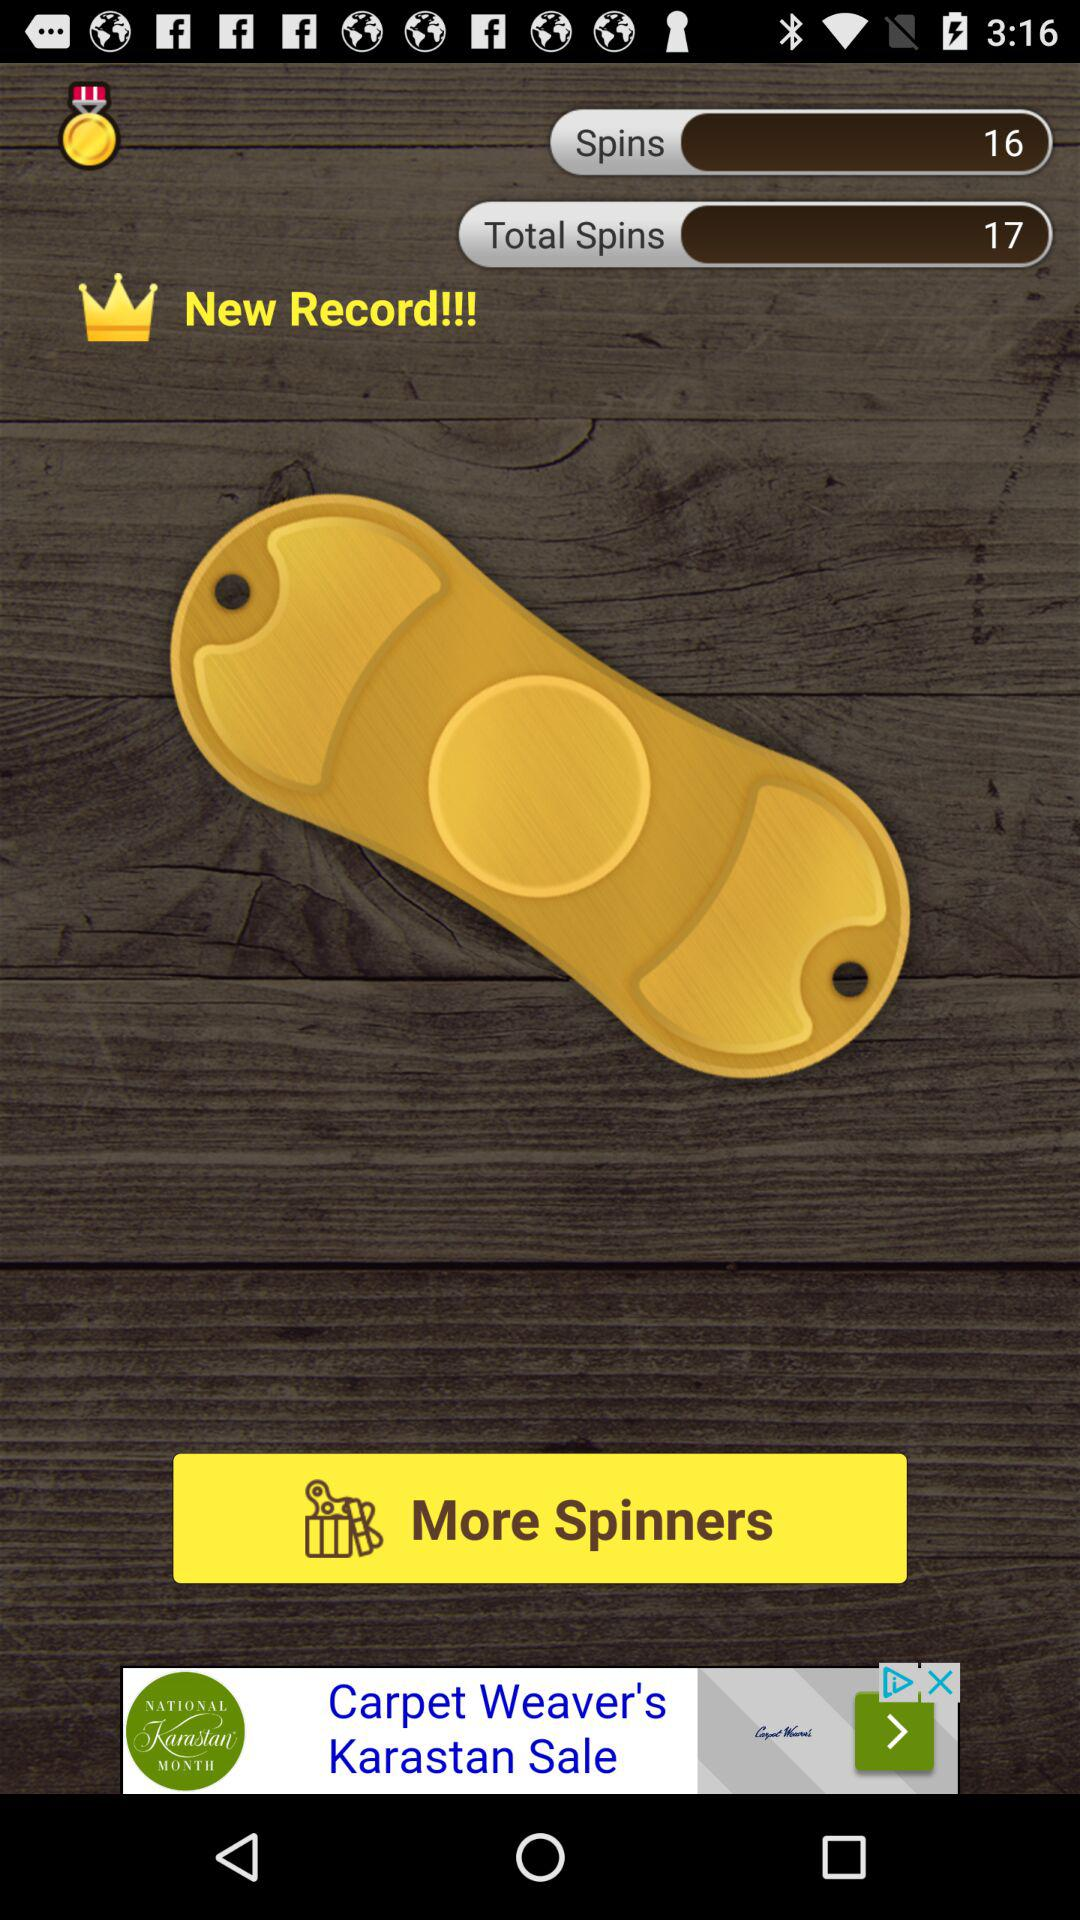How many records have been won?
When the provided information is insufficient, respond with <no answer>. <no answer> 